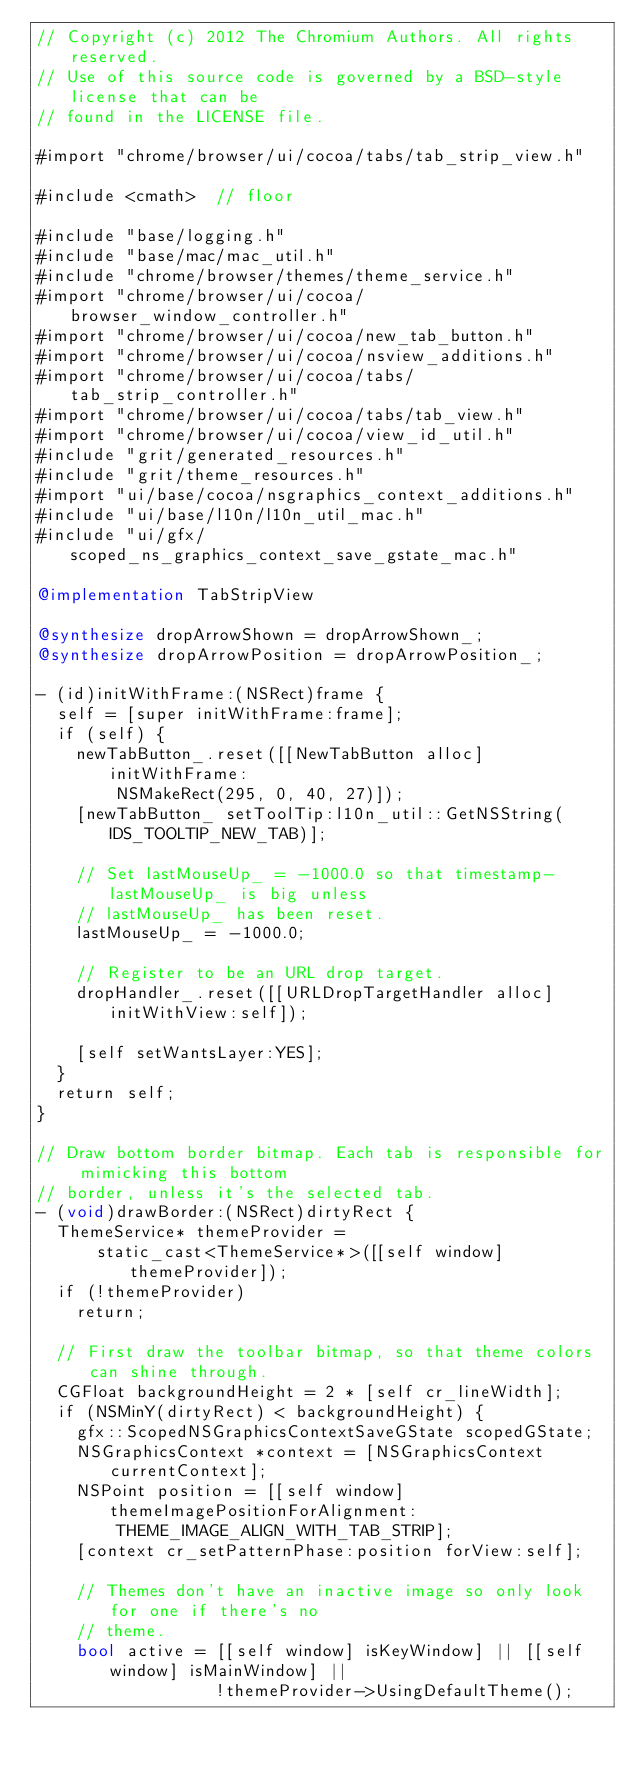Convert code to text. <code><loc_0><loc_0><loc_500><loc_500><_ObjectiveC_>// Copyright (c) 2012 The Chromium Authors. All rights reserved.
// Use of this source code is governed by a BSD-style license that can be
// found in the LICENSE file.

#import "chrome/browser/ui/cocoa/tabs/tab_strip_view.h"

#include <cmath>  // floor

#include "base/logging.h"
#include "base/mac/mac_util.h"
#include "chrome/browser/themes/theme_service.h"
#import "chrome/browser/ui/cocoa/browser_window_controller.h"
#import "chrome/browser/ui/cocoa/new_tab_button.h"
#import "chrome/browser/ui/cocoa/nsview_additions.h"
#import "chrome/browser/ui/cocoa/tabs/tab_strip_controller.h"
#import "chrome/browser/ui/cocoa/tabs/tab_view.h"
#import "chrome/browser/ui/cocoa/view_id_util.h"
#include "grit/generated_resources.h"
#include "grit/theme_resources.h"
#import "ui/base/cocoa/nsgraphics_context_additions.h"
#include "ui/base/l10n/l10n_util_mac.h"
#include "ui/gfx/scoped_ns_graphics_context_save_gstate_mac.h"

@implementation TabStripView

@synthesize dropArrowShown = dropArrowShown_;
@synthesize dropArrowPosition = dropArrowPosition_;

- (id)initWithFrame:(NSRect)frame {
  self = [super initWithFrame:frame];
  if (self) {
    newTabButton_.reset([[NewTabButton alloc] initWithFrame:
        NSMakeRect(295, 0, 40, 27)]);
    [newTabButton_ setToolTip:l10n_util::GetNSString(IDS_TOOLTIP_NEW_TAB)];

    // Set lastMouseUp_ = -1000.0 so that timestamp-lastMouseUp_ is big unless
    // lastMouseUp_ has been reset.
    lastMouseUp_ = -1000.0;

    // Register to be an URL drop target.
    dropHandler_.reset([[URLDropTargetHandler alloc] initWithView:self]);

    [self setWantsLayer:YES];
  }
  return self;
}

// Draw bottom border bitmap. Each tab is responsible for mimicking this bottom
// border, unless it's the selected tab.
- (void)drawBorder:(NSRect)dirtyRect {
  ThemeService* themeProvider =
      static_cast<ThemeService*>([[self window] themeProvider]);
  if (!themeProvider)
    return;

  // First draw the toolbar bitmap, so that theme colors can shine through.
  CGFloat backgroundHeight = 2 * [self cr_lineWidth];
  if (NSMinY(dirtyRect) < backgroundHeight) {
    gfx::ScopedNSGraphicsContextSaveGState scopedGState;
    NSGraphicsContext *context = [NSGraphicsContext currentContext];
    NSPoint position = [[self window] themeImagePositionForAlignment:
        THEME_IMAGE_ALIGN_WITH_TAB_STRIP];
    [context cr_setPatternPhase:position forView:self];

    // Themes don't have an inactive image so only look for one if there's no
    // theme.
    bool active = [[self window] isKeyWindow] || [[self window] isMainWindow] ||
                  !themeProvider->UsingDefaultTheme();</code> 